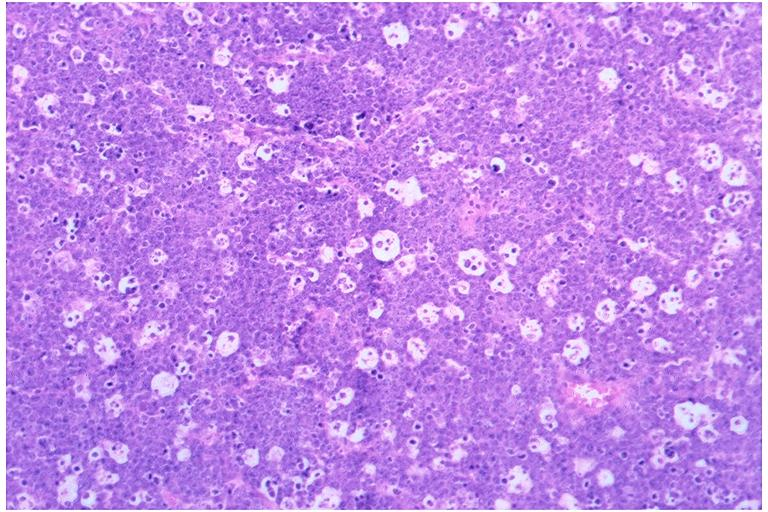does intraductal papillomatosis show burkits lymphoma?
Answer the question using a single word or phrase. No 